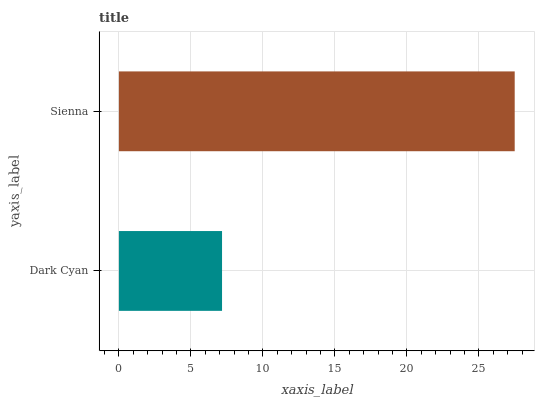Is Dark Cyan the minimum?
Answer yes or no. Yes. Is Sienna the maximum?
Answer yes or no. Yes. Is Sienna the minimum?
Answer yes or no. No. Is Sienna greater than Dark Cyan?
Answer yes or no. Yes. Is Dark Cyan less than Sienna?
Answer yes or no. Yes. Is Dark Cyan greater than Sienna?
Answer yes or no. No. Is Sienna less than Dark Cyan?
Answer yes or no. No. Is Sienna the high median?
Answer yes or no. Yes. Is Dark Cyan the low median?
Answer yes or no. Yes. Is Dark Cyan the high median?
Answer yes or no. No. Is Sienna the low median?
Answer yes or no. No. 